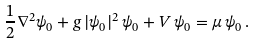Convert formula to latex. <formula><loc_0><loc_0><loc_500><loc_500>\frac { 1 } { 2 } \nabla ^ { 2 } \psi _ { 0 } + g \, | \psi _ { 0 } | ^ { 2 } \, \psi _ { 0 } + V \, \psi _ { 0 } = \mu \, \psi _ { 0 } \, .</formula> 